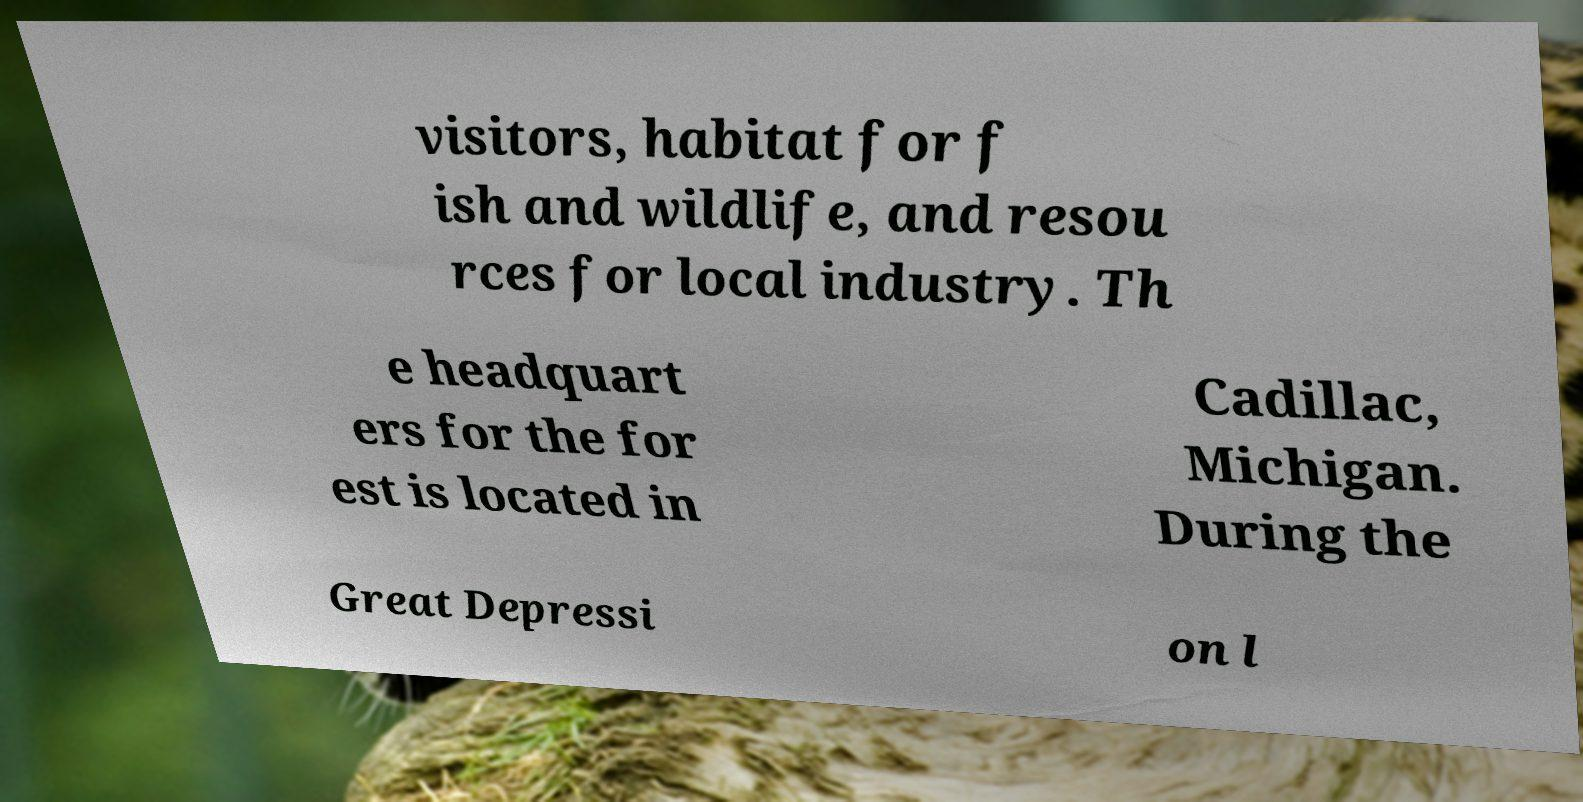I need the written content from this picture converted into text. Can you do that? visitors, habitat for f ish and wildlife, and resou rces for local industry. Th e headquart ers for the for est is located in Cadillac, Michigan. During the Great Depressi on l 